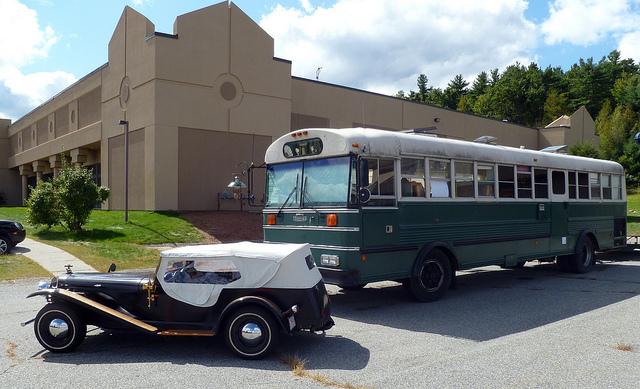Is the bus about to hit the car?
Give a very brief answer. No. Does the truck have airbags?
Quick response, please. No. What is the building in the background?
Keep it brief. School. What color is the sky?
Be succinct. Blue. What color is the house?
Keep it brief. Brown. How many blue barrels are there?
Write a very short answer. 0. Is this a trailer?
Be succinct. No. What type of car is this?
Concise answer only. Roadster. Is there a truck?
Be succinct. No. What kind of car is this?
Answer briefly. Old. Is the car for sale at a good price?
Be succinct. No. In what country was this picture taken?
Quick response, please. England. 